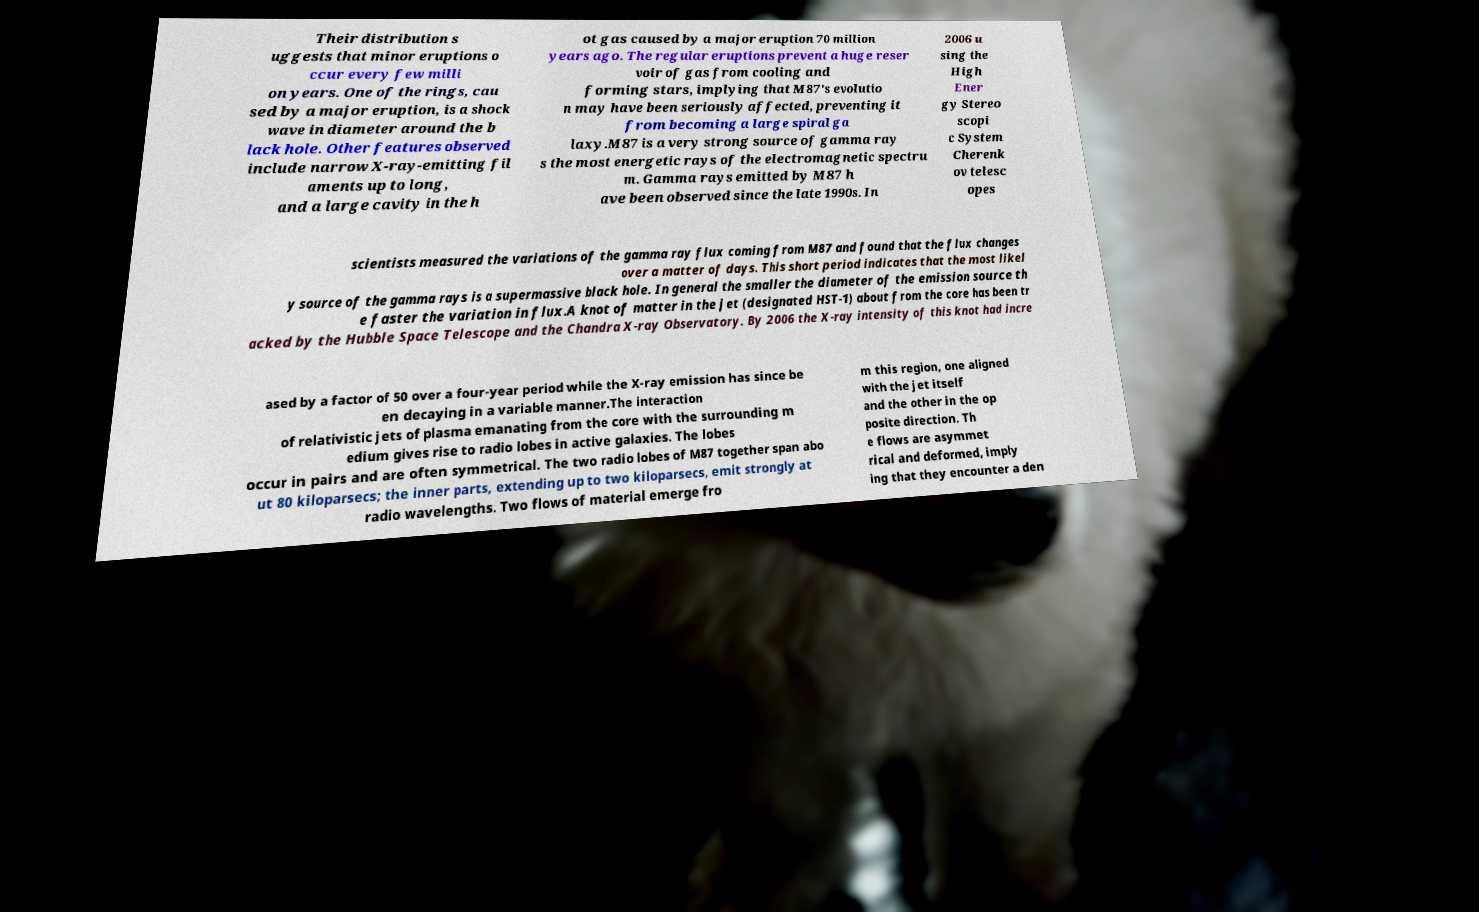There's text embedded in this image that I need extracted. Can you transcribe it verbatim? Their distribution s uggests that minor eruptions o ccur every few milli on years. One of the rings, cau sed by a major eruption, is a shock wave in diameter around the b lack hole. Other features observed include narrow X-ray-emitting fil aments up to long, and a large cavity in the h ot gas caused by a major eruption 70 million years ago. The regular eruptions prevent a huge reser voir of gas from cooling and forming stars, implying that M87's evolutio n may have been seriously affected, preventing it from becoming a large spiral ga laxy.M87 is a very strong source of gamma ray s the most energetic rays of the electromagnetic spectru m. Gamma rays emitted by M87 h ave been observed since the late 1990s. In 2006 u sing the High Ener gy Stereo scopi c System Cherenk ov telesc opes scientists measured the variations of the gamma ray flux coming from M87 and found that the flux changes over a matter of days. This short period indicates that the most likel y source of the gamma rays is a supermassive black hole. In general the smaller the diameter of the emission source th e faster the variation in flux.A knot of matter in the jet (designated HST-1) about from the core has been tr acked by the Hubble Space Telescope and the Chandra X-ray Observatory. By 2006 the X-ray intensity of this knot had incre ased by a factor of 50 over a four-year period while the X-ray emission has since be en decaying in a variable manner.The interaction of relativistic jets of plasma emanating from the core with the surrounding m edium gives rise to radio lobes in active galaxies. The lobes occur in pairs and are often symmetrical. The two radio lobes of M87 together span abo ut 80 kiloparsecs; the inner parts, extending up to two kiloparsecs, emit strongly at radio wavelengths. Two flows of material emerge fro m this region, one aligned with the jet itself and the other in the op posite direction. Th e flows are asymmet rical and deformed, imply ing that they encounter a den 